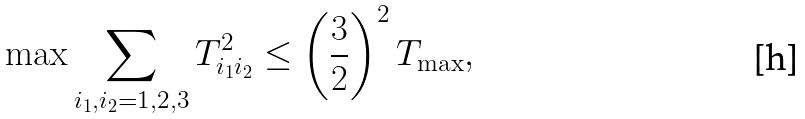<formula> <loc_0><loc_0><loc_500><loc_500>\max \sum _ { i _ { 1 } , i _ { 2 } = 1 , 2 , 3 } T _ { i _ { 1 } i _ { 2 } } ^ { 2 } \leq \left ( \frac { 3 } { 2 } \right ) ^ { 2 } T _ { \max } ,</formula> 